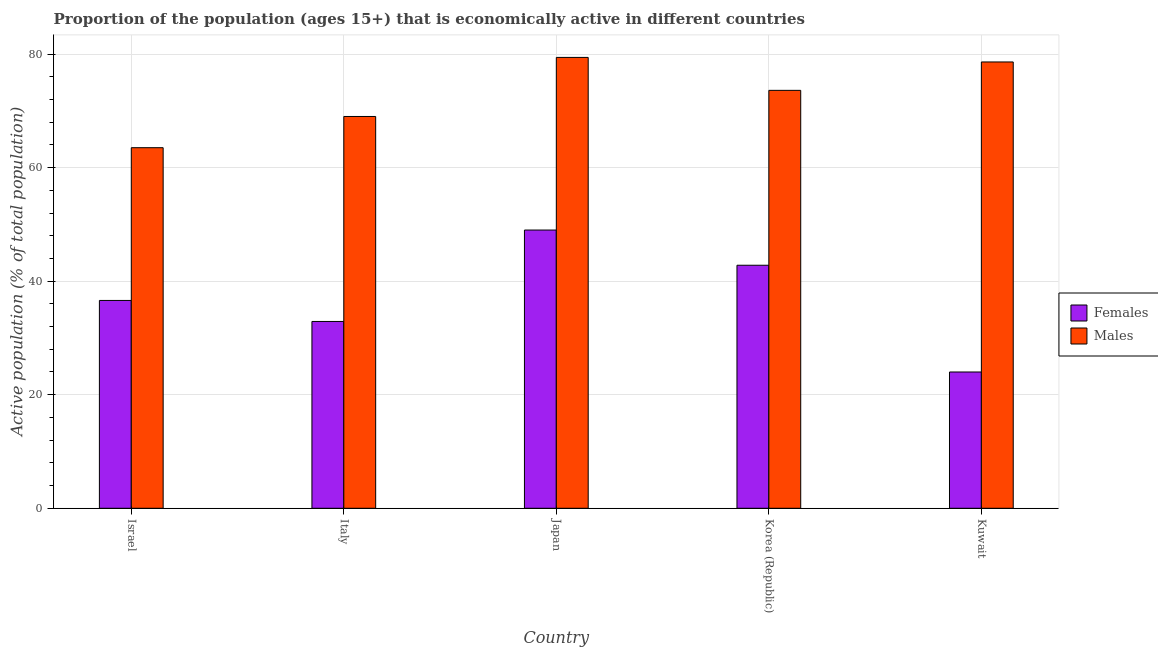How many groups of bars are there?
Your answer should be compact. 5. Are the number of bars on each tick of the X-axis equal?
Offer a very short reply. Yes. How many bars are there on the 3rd tick from the left?
Provide a short and direct response. 2. How many bars are there on the 2nd tick from the right?
Ensure brevity in your answer.  2. What is the label of the 4th group of bars from the left?
Offer a very short reply. Korea (Republic). In how many cases, is the number of bars for a given country not equal to the number of legend labels?
Ensure brevity in your answer.  0. What is the percentage of economically active female population in Italy?
Give a very brief answer. 32.9. In which country was the percentage of economically active male population minimum?
Offer a terse response. Israel. What is the total percentage of economically active female population in the graph?
Your response must be concise. 185.3. What is the difference between the percentage of economically active female population in Israel and that in Korea (Republic)?
Your answer should be compact. -6.2. What is the difference between the percentage of economically active female population in Japan and the percentage of economically active male population in Kuwait?
Provide a succinct answer. -29.6. What is the average percentage of economically active male population per country?
Your response must be concise. 72.82. What is the difference between the percentage of economically active male population and percentage of economically active female population in Korea (Republic)?
Your answer should be very brief. 30.8. What is the ratio of the percentage of economically active female population in Japan to that in Korea (Republic)?
Make the answer very short. 1.14. Is the percentage of economically active male population in Japan less than that in Kuwait?
Provide a short and direct response. No. What is the difference between the highest and the second highest percentage of economically active female population?
Give a very brief answer. 6.2. What does the 2nd bar from the left in Italy represents?
Your response must be concise. Males. What does the 2nd bar from the right in Korea (Republic) represents?
Keep it short and to the point. Females. How many bars are there?
Your answer should be very brief. 10. Are all the bars in the graph horizontal?
Give a very brief answer. No. What is the difference between two consecutive major ticks on the Y-axis?
Keep it short and to the point. 20. How are the legend labels stacked?
Your response must be concise. Vertical. What is the title of the graph?
Give a very brief answer. Proportion of the population (ages 15+) that is economically active in different countries. What is the label or title of the X-axis?
Your response must be concise. Country. What is the label or title of the Y-axis?
Your response must be concise. Active population (% of total population). What is the Active population (% of total population) in Females in Israel?
Offer a terse response. 36.6. What is the Active population (% of total population) in Males in Israel?
Provide a short and direct response. 63.5. What is the Active population (% of total population) of Females in Italy?
Give a very brief answer. 32.9. What is the Active population (% of total population) in Males in Italy?
Give a very brief answer. 69. What is the Active population (% of total population) in Females in Japan?
Your answer should be very brief. 49. What is the Active population (% of total population) in Males in Japan?
Ensure brevity in your answer.  79.4. What is the Active population (% of total population) of Females in Korea (Republic)?
Ensure brevity in your answer.  42.8. What is the Active population (% of total population) in Males in Korea (Republic)?
Ensure brevity in your answer.  73.6. What is the Active population (% of total population) of Females in Kuwait?
Provide a short and direct response. 24. What is the Active population (% of total population) in Males in Kuwait?
Give a very brief answer. 78.6. Across all countries, what is the maximum Active population (% of total population) of Females?
Make the answer very short. 49. Across all countries, what is the maximum Active population (% of total population) in Males?
Provide a short and direct response. 79.4. Across all countries, what is the minimum Active population (% of total population) in Males?
Ensure brevity in your answer.  63.5. What is the total Active population (% of total population) in Females in the graph?
Make the answer very short. 185.3. What is the total Active population (% of total population) of Males in the graph?
Provide a succinct answer. 364.1. What is the difference between the Active population (% of total population) of Females in Israel and that in Italy?
Make the answer very short. 3.7. What is the difference between the Active population (% of total population) of Females in Israel and that in Japan?
Your response must be concise. -12.4. What is the difference between the Active population (% of total population) in Males in Israel and that in Japan?
Make the answer very short. -15.9. What is the difference between the Active population (% of total population) in Males in Israel and that in Korea (Republic)?
Your response must be concise. -10.1. What is the difference between the Active population (% of total population) of Females in Israel and that in Kuwait?
Make the answer very short. 12.6. What is the difference between the Active population (% of total population) in Males in Israel and that in Kuwait?
Keep it short and to the point. -15.1. What is the difference between the Active population (% of total population) in Females in Italy and that in Japan?
Provide a short and direct response. -16.1. What is the difference between the Active population (% of total population) in Females in Japan and that in Korea (Republic)?
Provide a succinct answer. 6.2. What is the difference between the Active population (% of total population) in Males in Japan and that in Korea (Republic)?
Your response must be concise. 5.8. What is the difference between the Active population (% of total population) in Females in Israel and the Active population (% of total population) in Males in Italy?
Your answer should be very brief. -32.4. What is the difference between the Active population (% of total population) in Females in Israel and the Active population (% of total population) in Males in Japan?
Ensure brevity in your answer.  -42.8. What is the difference between the Active population (% of total population) of Females in Israel and the Active population (% of total population) of Males in Korea (Republic)?
Make the answer very short. -37. What is the difference between the Active population (% of total population) in Females in Israel and the Active population (% of total population) in Males in Kuwait?
Make the answer very short. -42. What is the difference between the Active population (% of total population) in Females in Italy and the Active population (% of total population) in Males in Japan?
Keep it short and to the point. -46.5. What is the difference between the Active population (% of total population) of Females in Italy and the Active population (% of total population) of Males in Korea (Republic)?
Make the answer very short. -40.7. What is the difference between the Active population (% of total population) of Females in Italy and the Active population (% of total population) of Males in Kuwait?
Provide a short and direct response. -45.7. What is the difference between the Active population (% of total population) in Females in Japan and the Active population (% of total population) in Males in Korea (Republic)?
Keep it short and to the point. -24.6. What is the difference between the Active population (% of total population) of Females in Japan and the Active population (% of total population) of Males in Kuwait?
Make the answer very short. -29.6. What is the difference between the Active population (% of total population) of Females in Korea (Republic) and the Active population (% of total population) of Males in Kuwait?
Provide a succinct answer. -35.8. What is the average Active population (% of total population) of Females per country?
Offer a very short reply. 37.06. What is the average Active population (% of total population) in Males per country?
Provide a short and direct response. 72.82. What is the difference between the Active population (% of total population) in Females and Active population (% of total population) in Males in Israel?
Your answer should be very brief. -26.9. What is the difference between the Active population (% of total population) in Females and Active population (% of total population) in Males in Italy?
Offer a terse response. -36.1. What is the difference between the Active population (% of total population) in Females and Active population (% of total population) in Males in Japan?
Ensure brevity in your answer.  -30.4. What is the difference between the Active population (% of total population) of Females and Active population (% of total population) of Males in Korea (Republic)?
Provide a short and direct response. -30.8. What is the difference between the Active population (% of total population) in Females and Active population (% of total population) in Males in Kuwait?
Provide a short and direct response. -54.6. What is the ratio of the Active population (% of total population) in Females in Israel to that in Italy?
Your response must be concise. 1.11. What is the ratio of the Active population (% of total population) of Males in Israel to that in Italy?
Your answer should be compact. 0.92. What is the ratio of the Active population (% of total population) in Females in Israel to that in Japan?
Offer a terse response. 0.75. What is the ratio of the Active population (% of total population) of Males in Israel to that in Japan?
Your response must be concise. 0.8. What is the ratio of the Active population (% of total population) in Females in Israel to that in Korea (Republic)?
Offer a very short reply. 0.86. What is the ratio of the Active population (% of total population) in Males in Israel to that in Korea (Republic)?
Offer a very short reply. 0.86. What is the ratio of the Active population (% of total population) in Females in Israel to that in Kuwait?
Your answer should be compact. 1.52. What is the ratio of the Active population (% of total population) of Males in Israel to that in Kuwait?
Keep it short and to the point. 0.81. What is the ratio of the Active population (% of total population) in Females in Italy to that in Japan?
Offer a very short reply. 0.67. What is the ratio of the Active population (% of total population) of Males in Italy to that in Japan?
Provide a short and direct response. 0.87. What is the ratio of the Active population (% of total population) of Females in Italy to that in Korea (Republic)?
Keep it short and to the point. 0.77. What is the ratio of the Active population (% of total population) of Females in Italy to that in Kuwait?
Provide a succinct answer. 1.37. What is the ratio of the Active population (% of total population) of Males in Italy to that in Kuwait?
Your answer should be compact. 0.88. What is the ratio of the Active population (% of total population) in Females in Japan to that in Korea (Republic)?
Keep it short and to the point. 1.14. What is the ratio of the Active population (% of total population) in Males in Japan to that in Korea (Republic)?
Keep it short and to the point. 1.08. What is the ratio of the Active population (% of total population) of Females in Japan to that in Kuwait?
Provide a succinct answer. 2.04. What is the ratio of the Active population (% of total population) of Males in Japan to that in Kuwait?
Your answer should be very brief. 1.01. What is the ratio of the Active population (% of total population) in Females in Korea (Republic) to that in Kuwait?
Provide a short and direct response. 1.78. What is the ratio of the Active population (% of total population) in Males in Korea (Republic) to that in Kuwait?
Provide a succinct answer. 0.94. What is the difference between the highest and the second highest Active population (% of total population) of Females?
Make the answer very short. 6.2. What is the difference between the highest and the second highest Active population (% of total population) in Males?
Your answer should be very brief. 0.8. What is the difference between the highest and the lowest Active population (% of total population) of Females?
Make the answer very short. 25. 